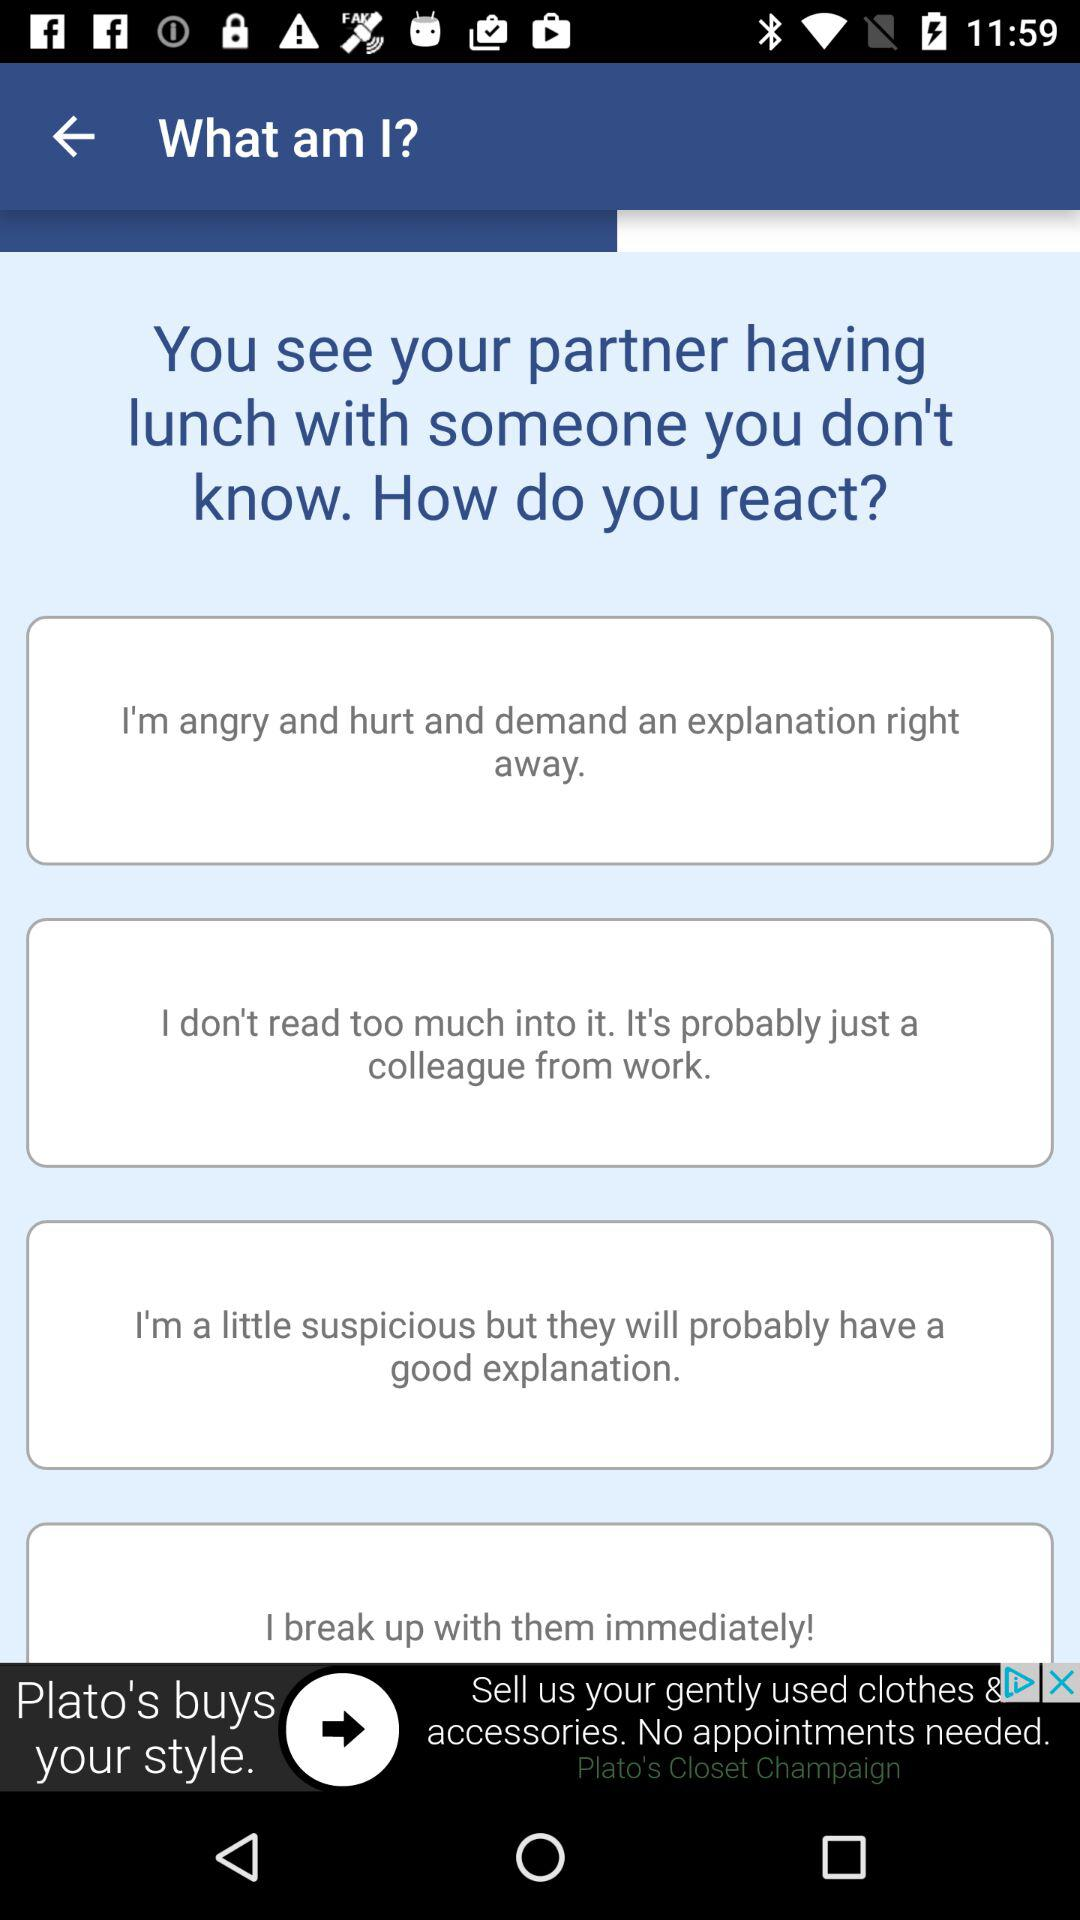How many options are there for how to react when you see your partner having lunch with someone you don't know?
Answer the question using a single word or phrase. 4 